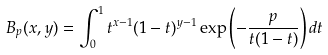Convert formula to latex. <formula><loc_0><loc_0><loc_500><loc_500>B _ { p } ( x , y ) = \int _ { 0 } ^ { 1 } t ^ { x - 1 } ( 1 - t ) ^ { y - 1 } \exp \left ( - \frac { p } { t ( 1 - t ) } \right ) d t</formula> 